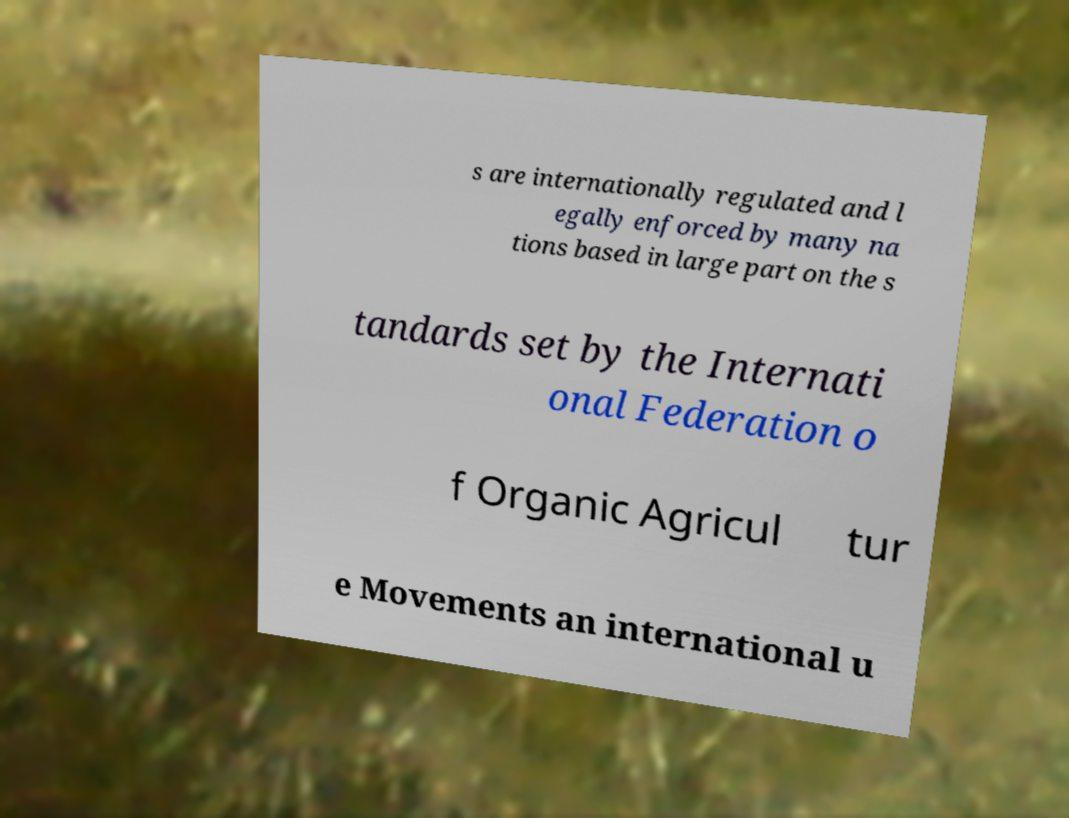What messages or text are displayed in this image? I need them in a readable, typed format. s are internationally regulated and l egally enforced by many na tions based in large part on the s tandards set by the Internati onal Federation o f Organic Agricul tur e Movements an international u 